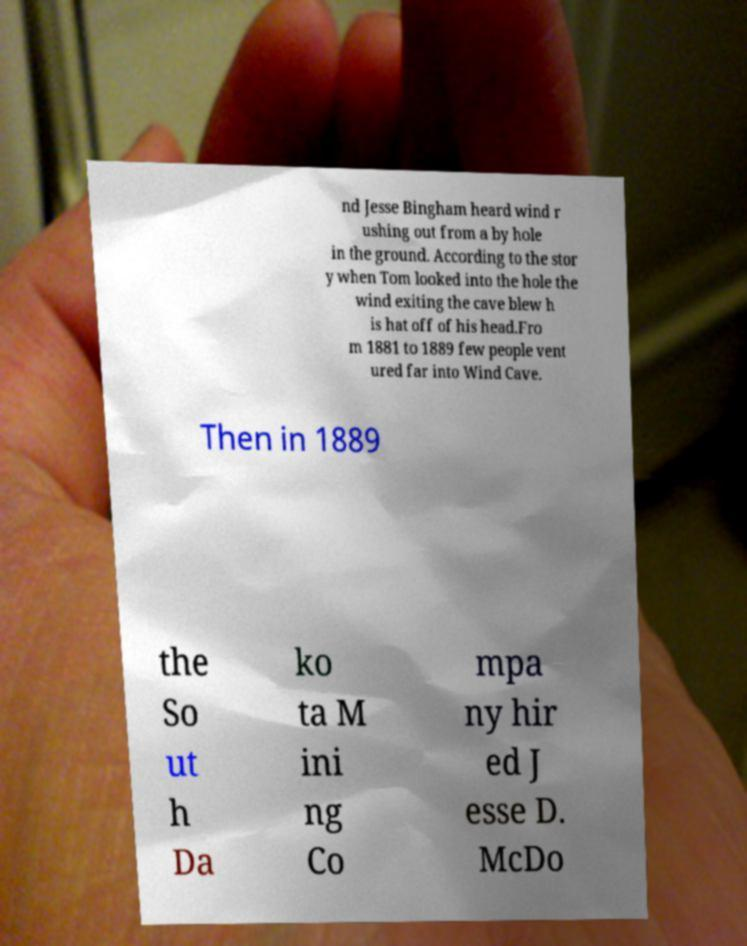Can you read and provide the text displayed in the image?This photo seems to have some interesting text. Can you extract and type it out for me? nd Jesse Bingham heard wind r ushing out from a by hole in the ground. According to the stor y when Tom looked into the hole the wind exiting the cave blew h is hat off of his head.Fro m 1881 to 1889 few people vent ured far into Wind Cave. Then in 1889 the So ut h Da ko ta M ini ng Co mpa ny hir ed J esse D. McDo 